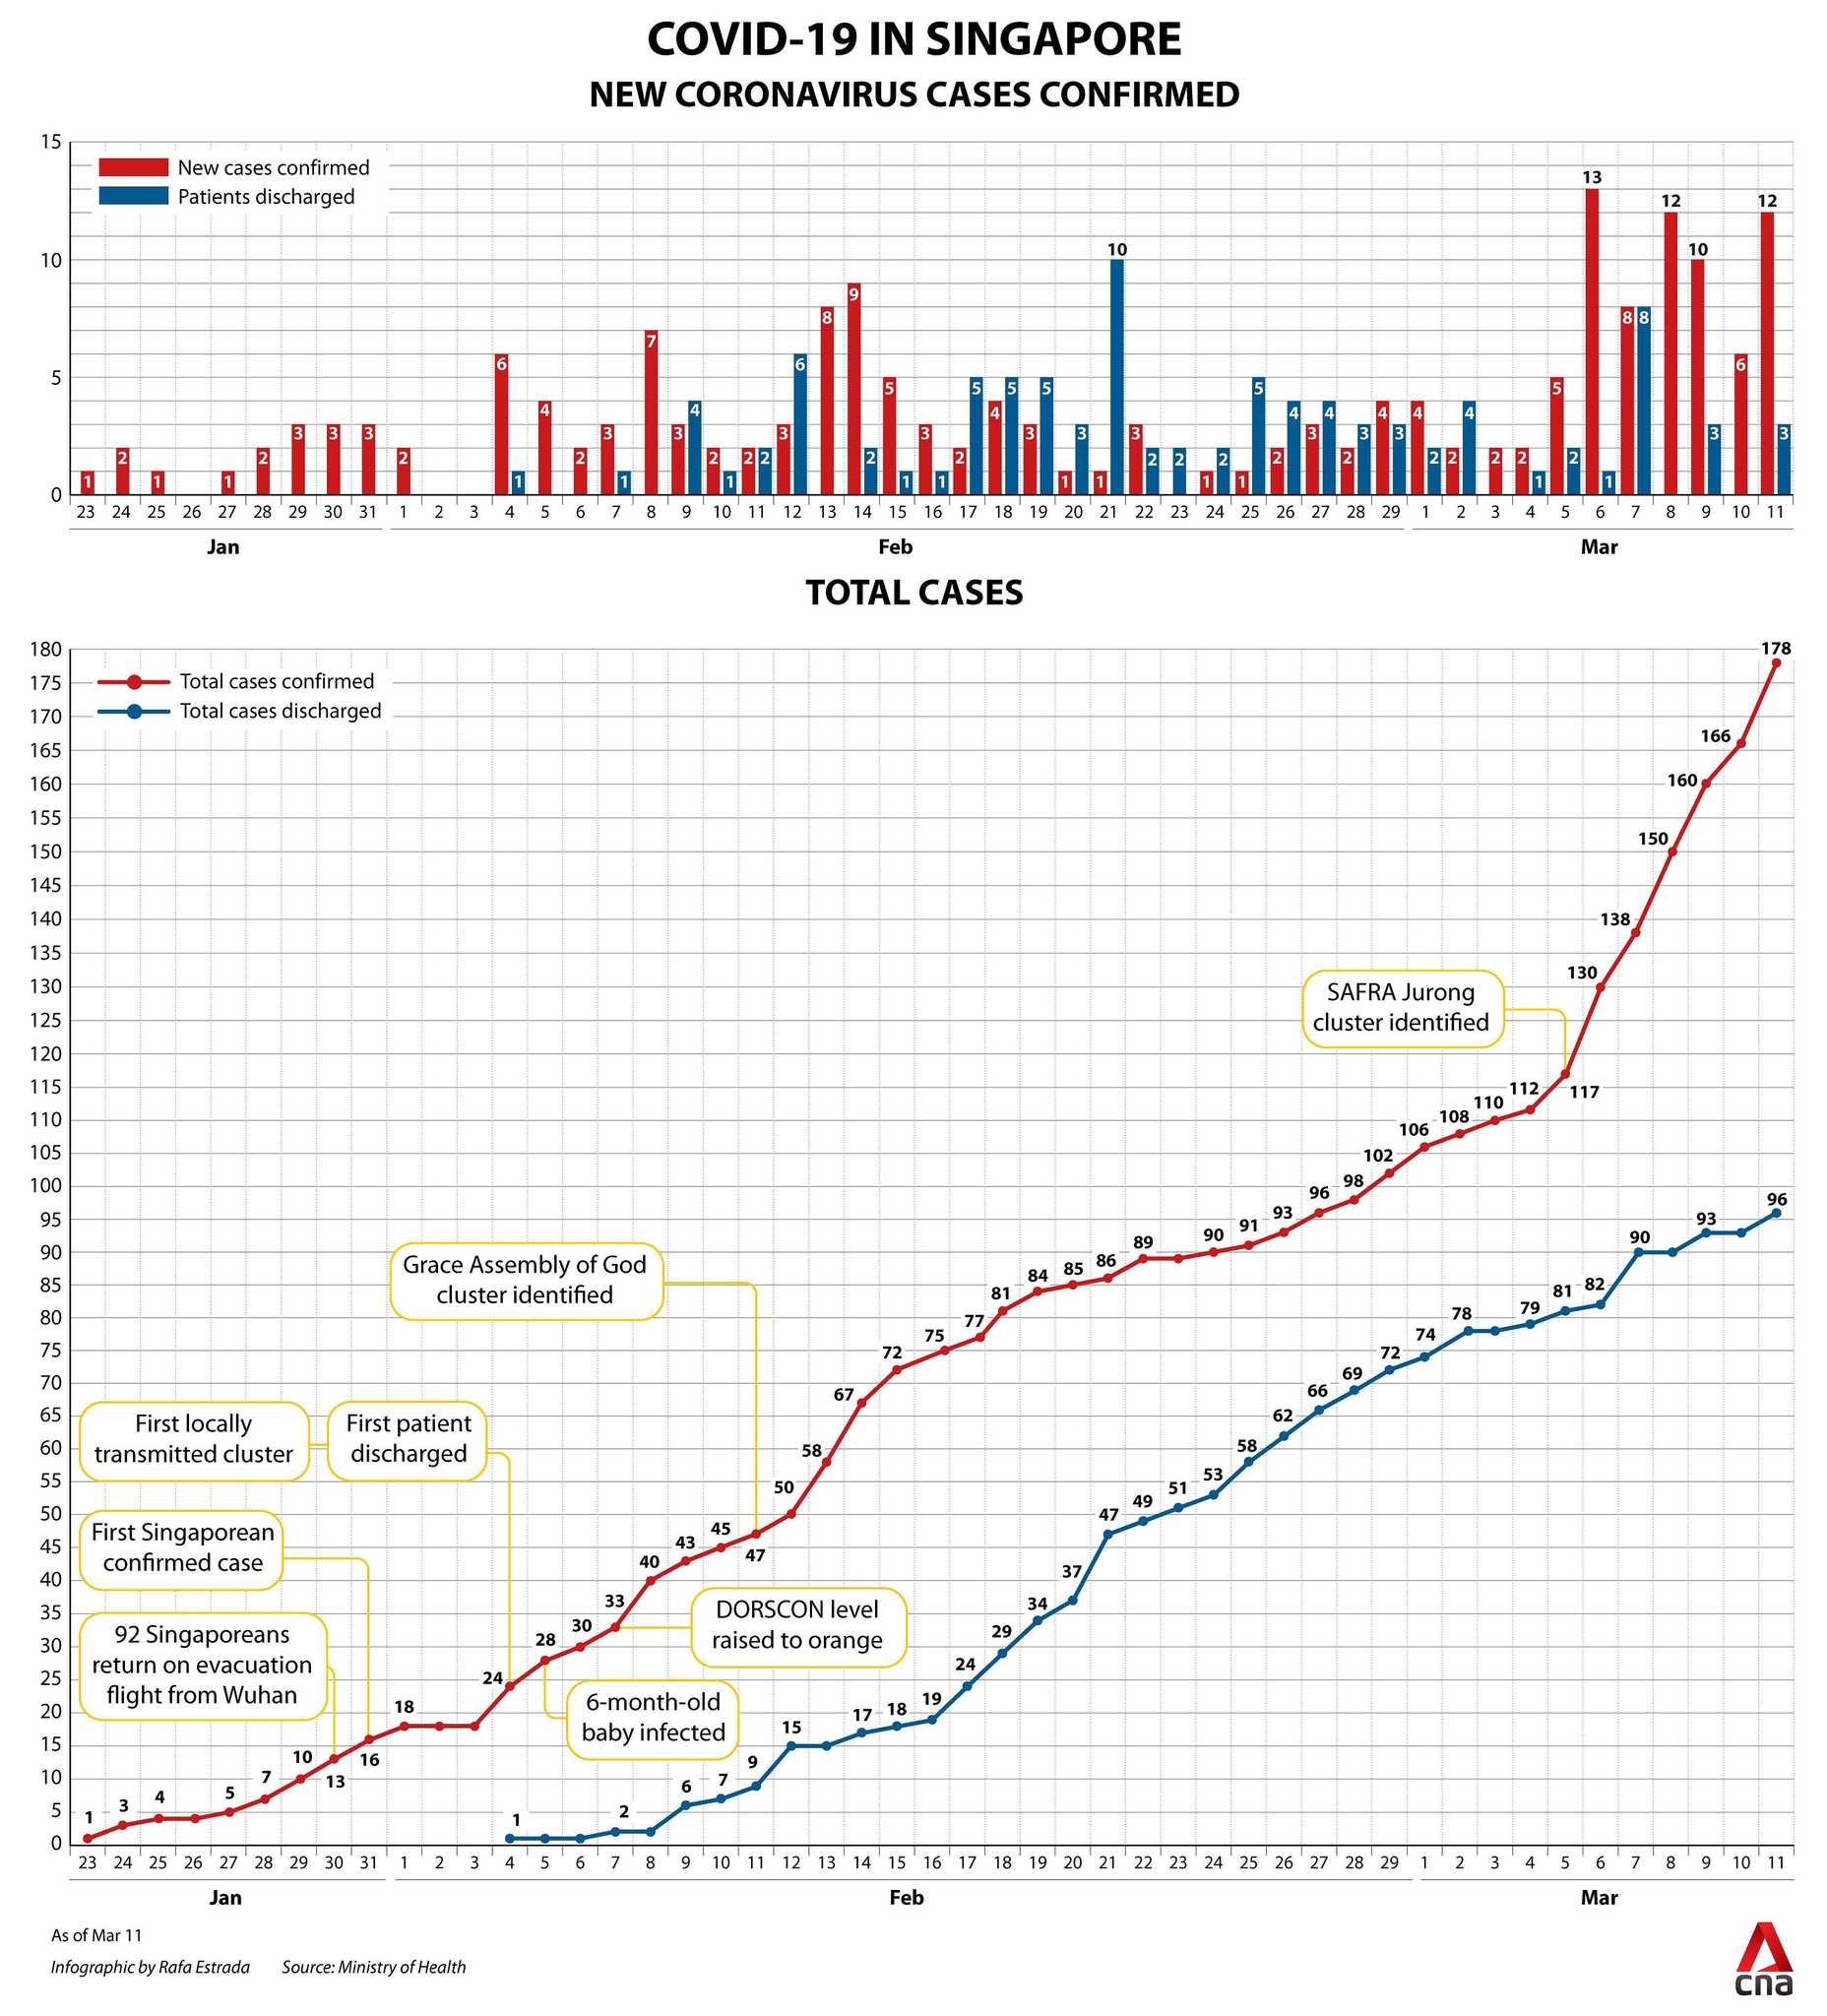What is the total number of Covid-19 cases identified in Grace Assembly of God cluster in Singapore?
Answer the question with a short phrase. 47 What is the highest number of new Covid-19 cases confirmed on Feb 2020 in Singapore? 9 When was the least number of total Covid-19 cases discharged in Singapore? Feb 4 What is the second highest number of total Covid-19 cases discharged in the month of March in Singapore? 93 What is the number of new Covid-19 cases confirmed on March 11 in Singapore? 12 What is the least number of total Covid-19 cases confirmed on March in Singapore? 106 What is the highest number of new Covid-19 cases confirmed on March 2020 in Singapore? 13 What is the number of new Covid-19 cases confirmed on Feb13 in Singapore? 8 What is the total number of Covid-19 cases identified in SAFRA Jurong cluster in Singapore? 117 What is the highest number of total Covid-19 cases discharged in the month of February in Singapore? 72 